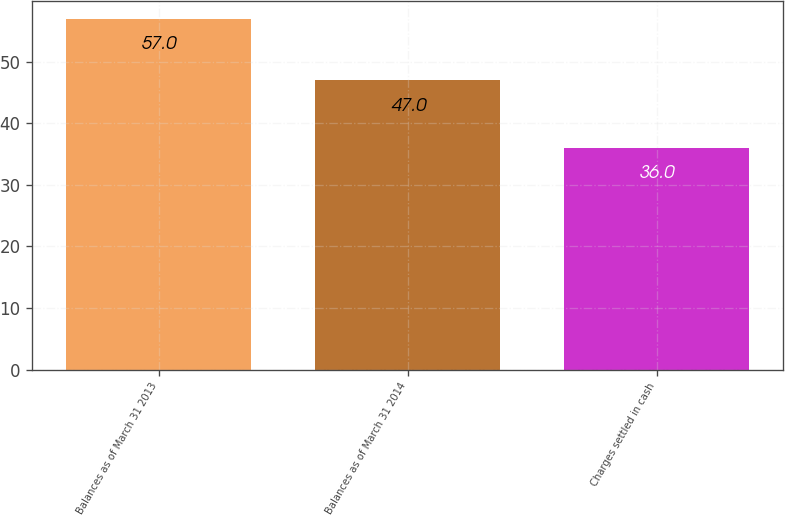Convert chart. <chart><loc_0><loc_0><loc_500><loc_500><bar_chart><fcel>Balances as of March 31 2013<fcel>Balances as of March 31 2014<fcel>Charges settled in cash<nl><fcel>57<fcel>47<fcel>36<nl></chart> 